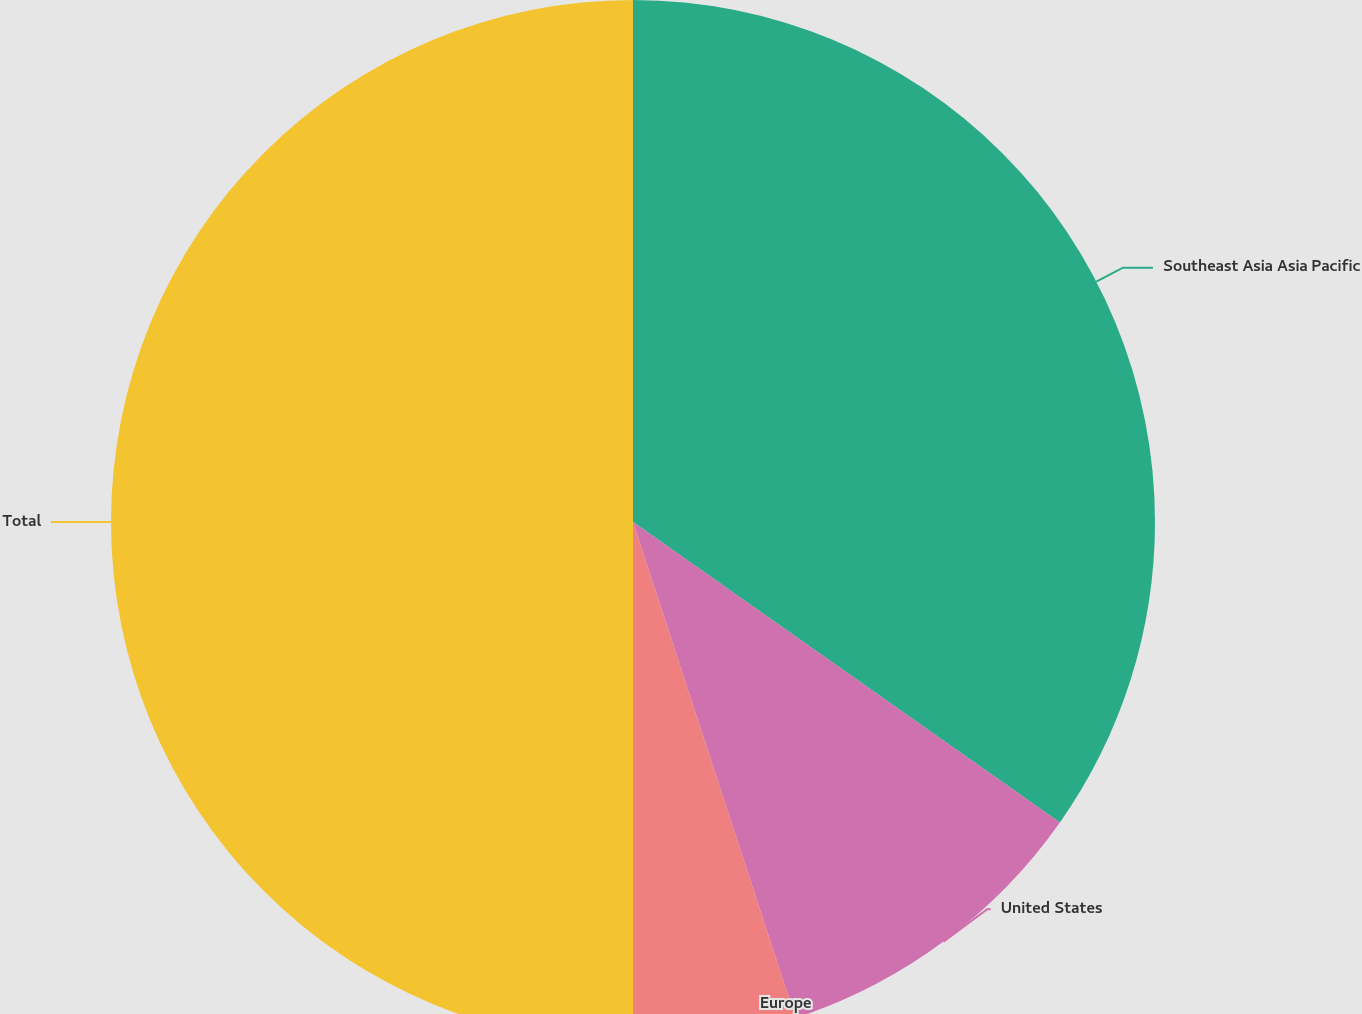Convert chart. <chart><loc_0><loc_0><loc_500><loc_500><pie_chart><fcel>Southeast Asia Asia Pacific<fcel>United States<fcel>Europe<fcel>Total<nl><fcel>34.76%<fcel>10.2%<fcel>5.04%<fcel>50.0%<nl></chart> 